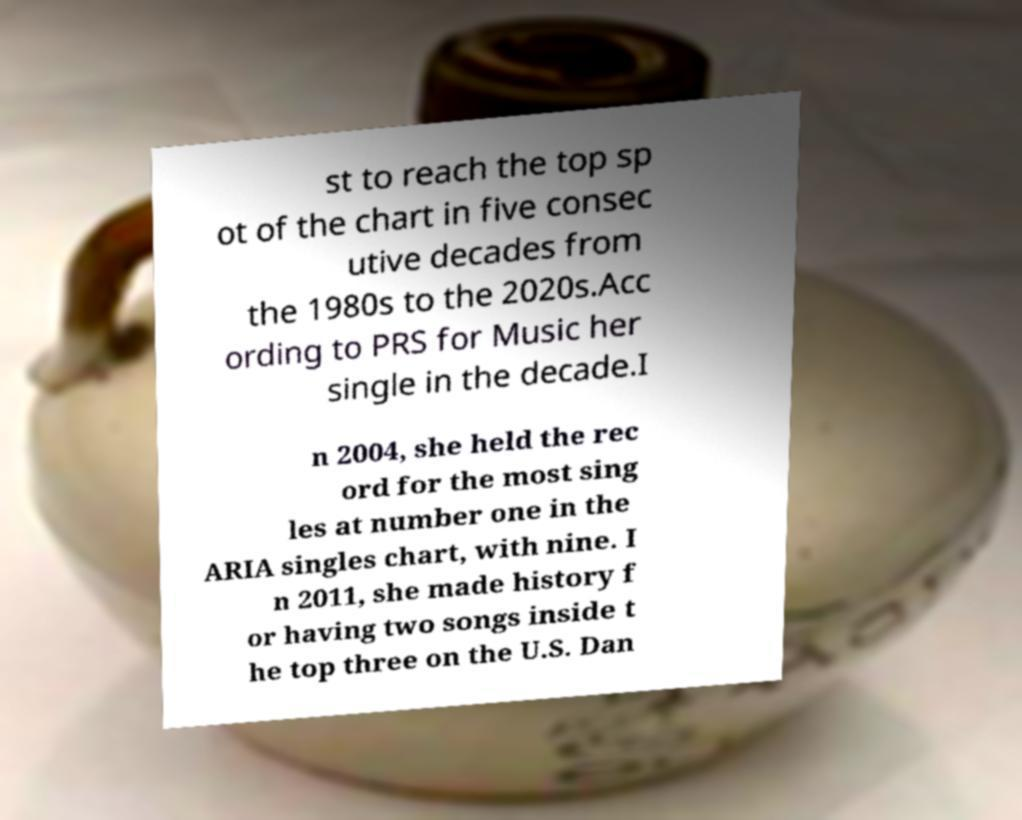Could you assist in decoding the text presented in this image and type it out clearly? st to reach the top sp ot of the chart in five consec utive decades from the 1980s to the 2020s.Acc ording to PRS for Music her single in the decade.I n 2004, she held the rec ord for the most sing les at number one in the ARIA singles chart, with nine. I n 2011, she made history f or having two songs inside t he top three on the U.S. Dan 